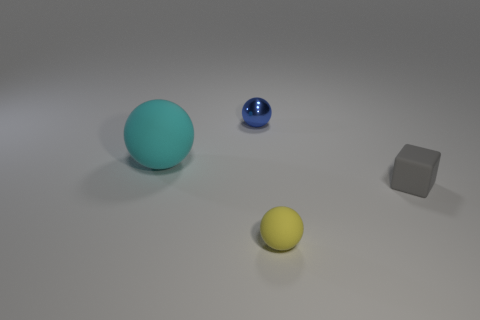There is a yellow rubber thing; are there any tiny rubber objects to the right of it?
Your response must be concise. Yes. What is the color of the rubber ball in front of the matte object that is to the right of the sphere that is right of the tiny blue shiny ball?
Offer a very short reply. Yellow. How many tiny things are to the left of the small gray matte block and behind the yellow rubber thing?
Give a very brief answer. 1. What number of blocks are either small things or large brown metal objects?
Provide a succinct answer. 1. Are any gray matte blocks visible?
Offer a terse response. Yes. How many other things are there of the same material as the small yellow sphere?
Make the answer very short. 2. What material is the blue sphere that is the same size as the gray object?
Make the answer very short. Metal. Does the object left of the small blue shiny sphere have the same shape as the gray matte thing?
Offer a terse response. No. Does the big rubber sphere have the same color as the small shiny thing?
Make the answer very short. No. How many objects are tiny things that are on the left side of the gray cube or large cyan spheres?
Provide a short and direct response. 3. 